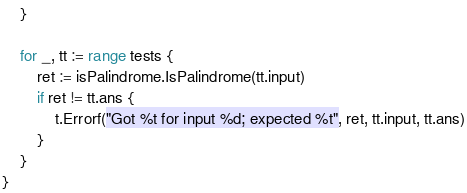<code> <loc_0><loc_0><loc_500><loc_500><_Go_>	}

	for _, tt := range tests {
		ret := isPalindrome.IsPalindrome(tt.input)
		if ret != tt.ans {
			t.Errorf("Got %t for input %d; expected %t", ret, tt.input, tt.ans)
		}
	}
}
</code> 